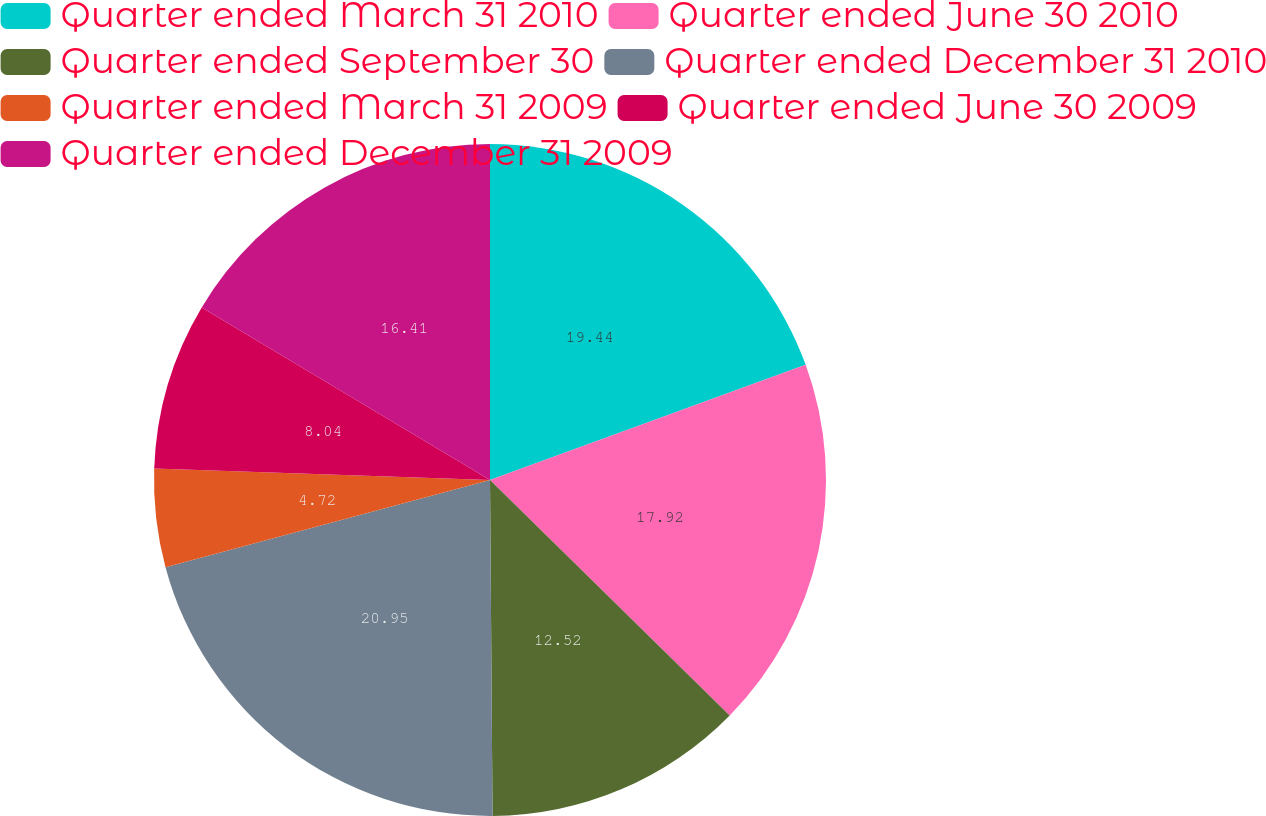Convert chart. <chart><loc_0><loc_0><loc_500><loc_500><pie_chart><fcel>Quarter ended March 31 2010<fcel>Quarter ended June 30 2010<fcel>Quarter ended September 30<fcel>Quarter ended December 31 2010<fcel>Quarter ended March 31 2009<fcel>Quarter ended June 30 2009<fcel>Quarter ended December 31 2009<nl><fcel>19.43%<fcel>17.92%<fcel>12.52%<fcel>20.94%<fcel>4.72%<fcel>8.04%<fcel>16.41%<nl></chart> 